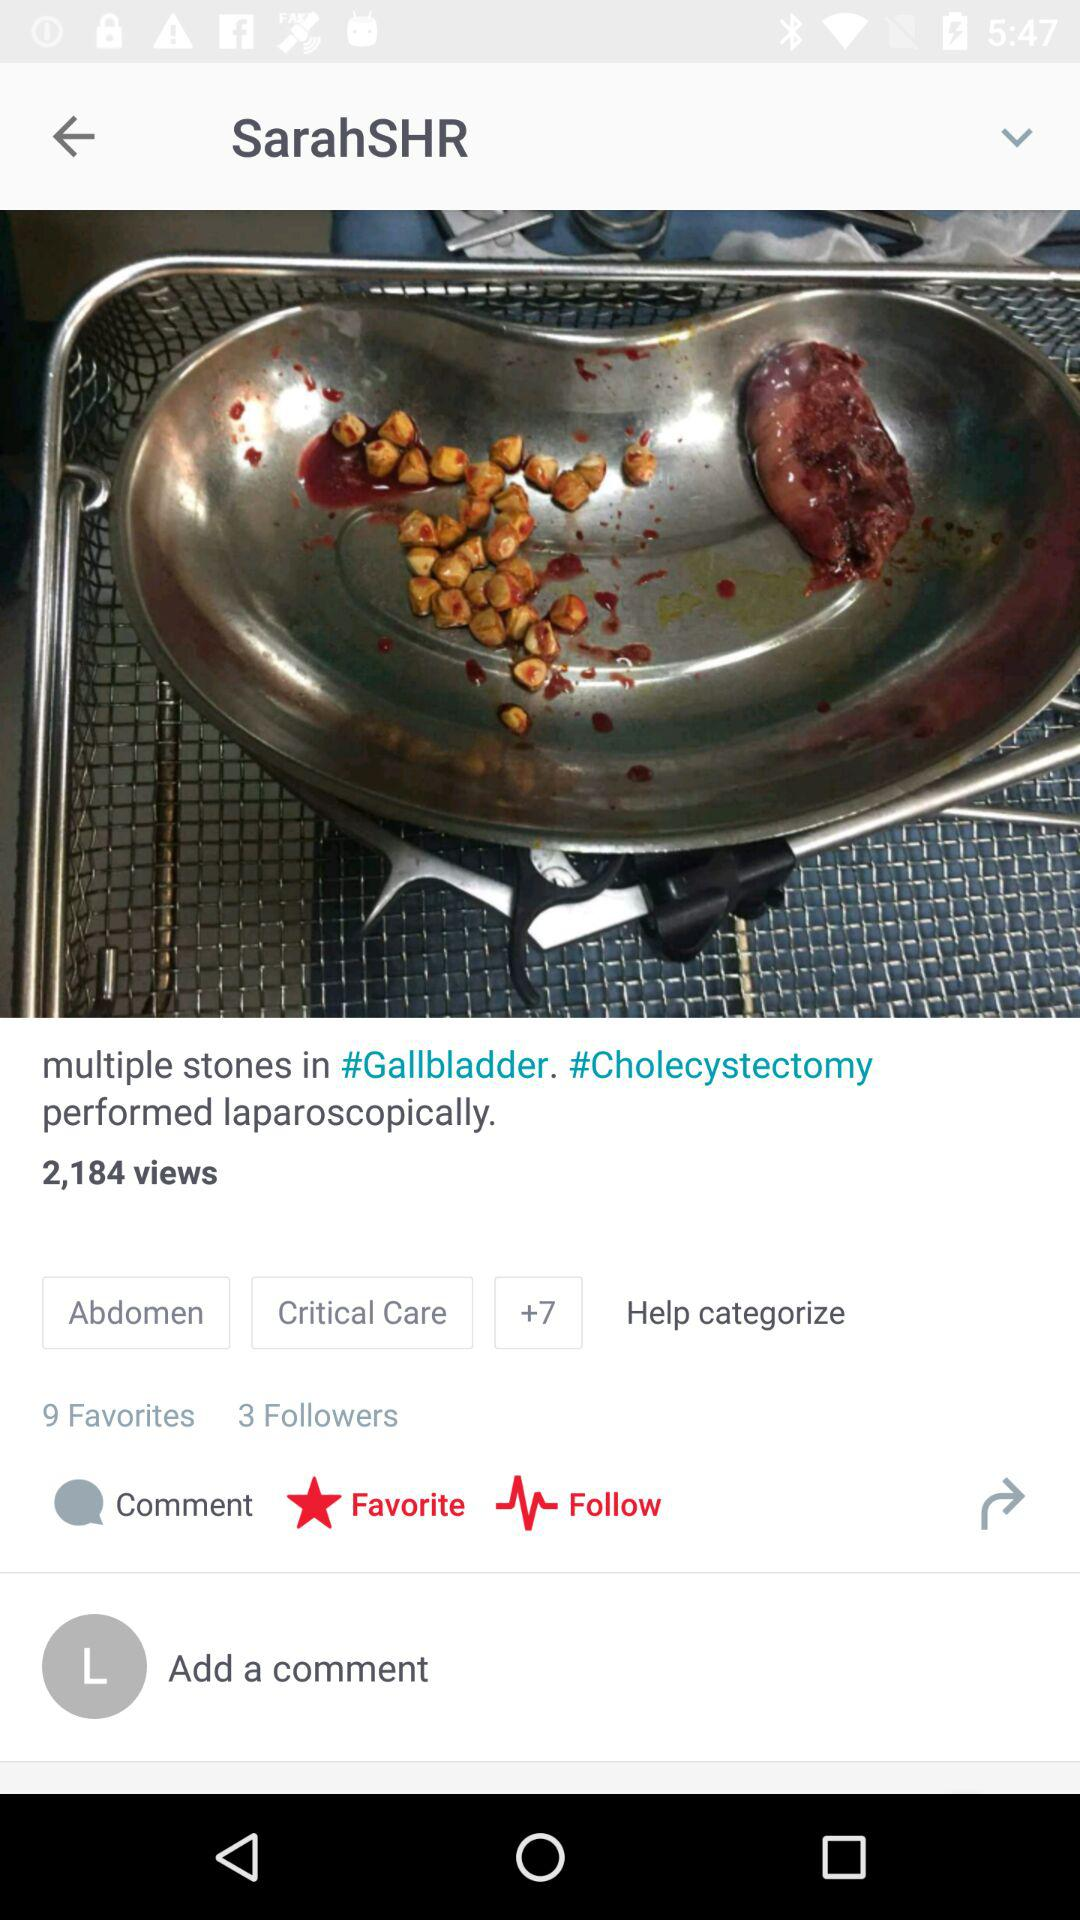What is the application name? The application name is "Figure 1". 